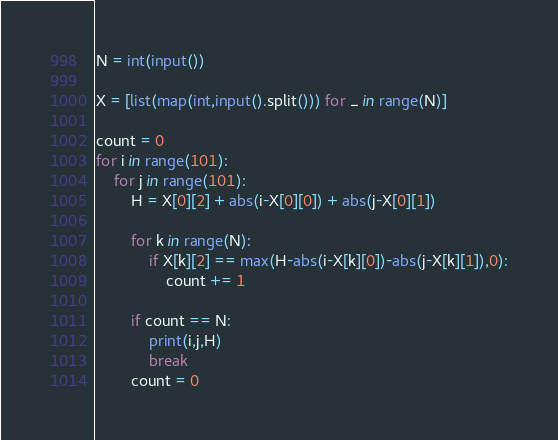Convert code to text. <code><loc_0><loc_0><loc_500><loc_500><_Python_>N = int(input())

X = [list(map(int,input().split())) for _ in range(N)]

count = 0
for i in range(101):
	for j in range(101):
		H = X[0][2] + abs(i-X[0][0]) + abs(j-X[0][1])

		for k in range(N):
			if X[k][2] == max(H-abs(i-X[k][0])-abs(j-X[k][1]),0):
				count += 1
		
		if count == N:
			print(i,j,H)
			break
		count = 0</code> 